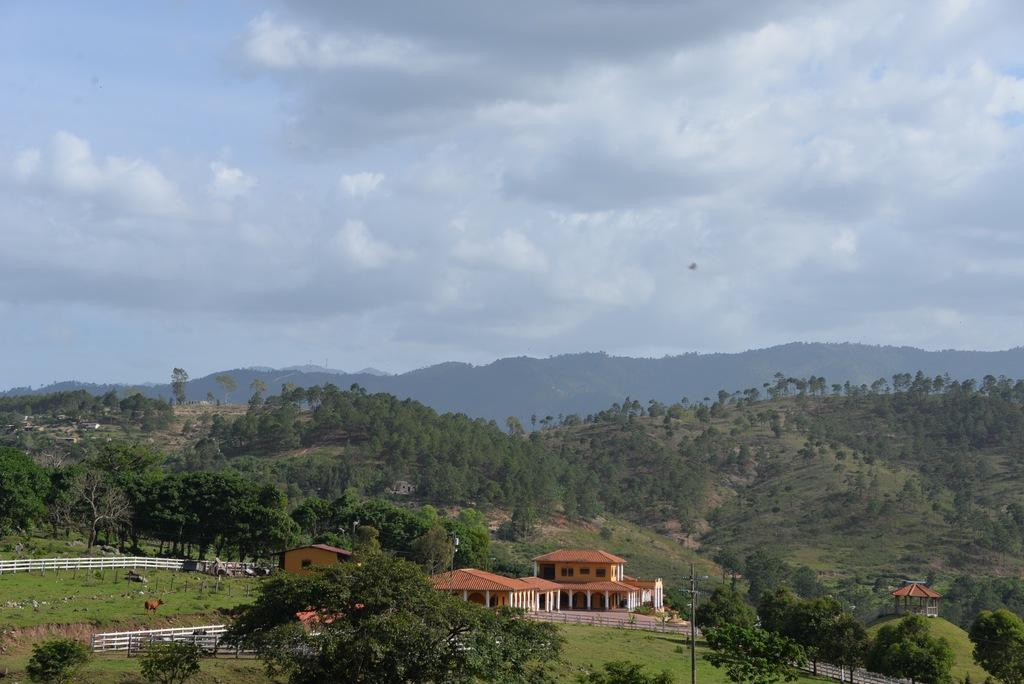What type of fencing can be seen in the image? There is white color fencing in the image. What structures are visible in the image? There are houses in the image. What material is present in the image? Glass is present in the image. What natural features can be seen in the image? Trees are visible on the mountains in the image. What is the condition of the sky in the image? The sky is covered with clouds. Can you tell me where the engine is located in the image? There is no engine present in the image. What type of jail can be seen in the image? There is no jail present in the image. 